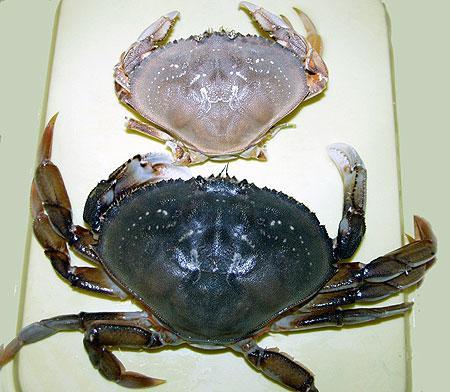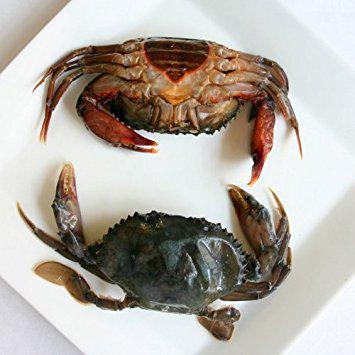The first image is the image on the left, the second image is the image on the right. Assess this claim about the two images: "The left image contains one forward-facing crab with its front claws somewhat extended and its top shell visible.". Correct or not? Answer yes or no. No. 